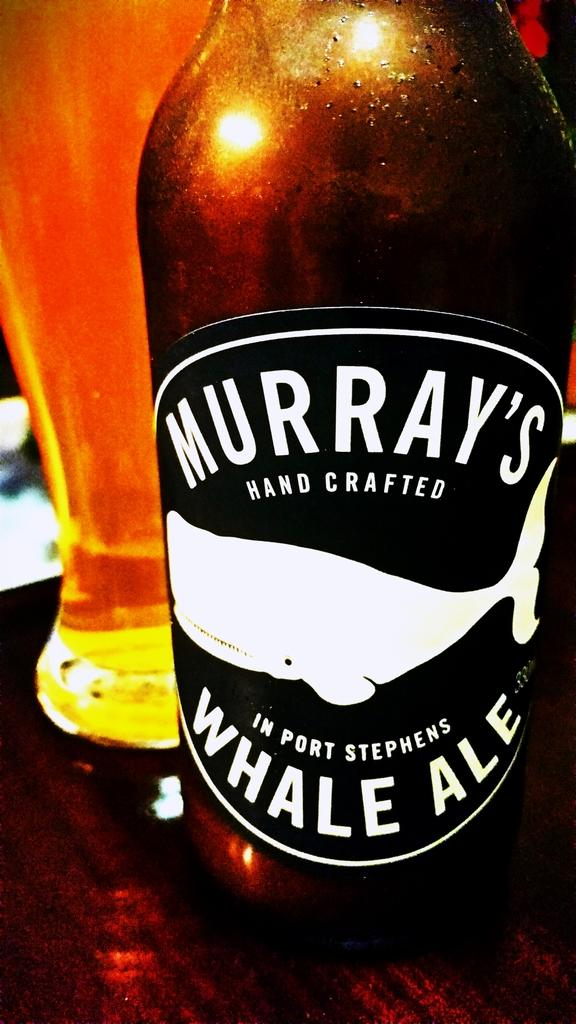<image>
Write a terse but informative summary of the picture. A bottle of Murray's Whale Ale sits in front of a glass filled with beer. 